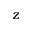Convert formula to latex. <formula><loc_0><loc_0><loc_500><loc_500>z</formula> 